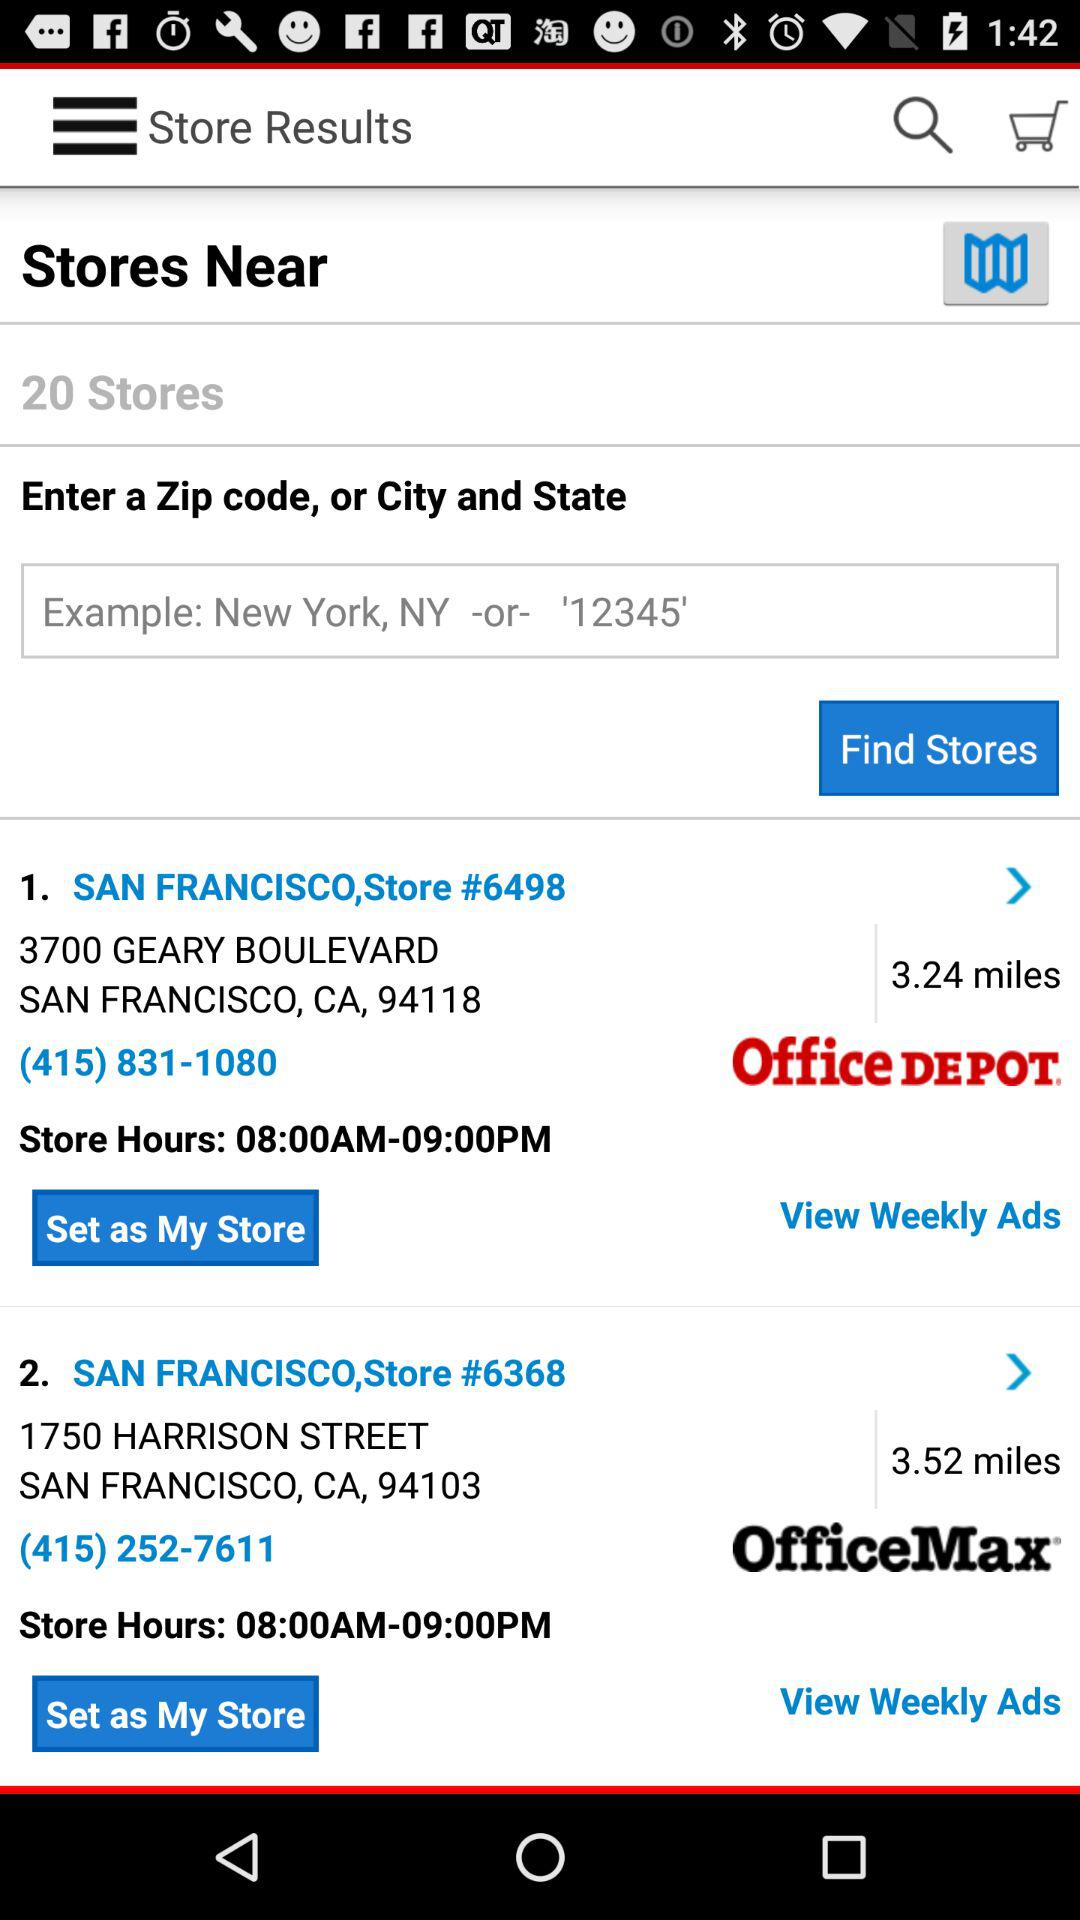How many stores are nearby? There are 20 nearby stores. 